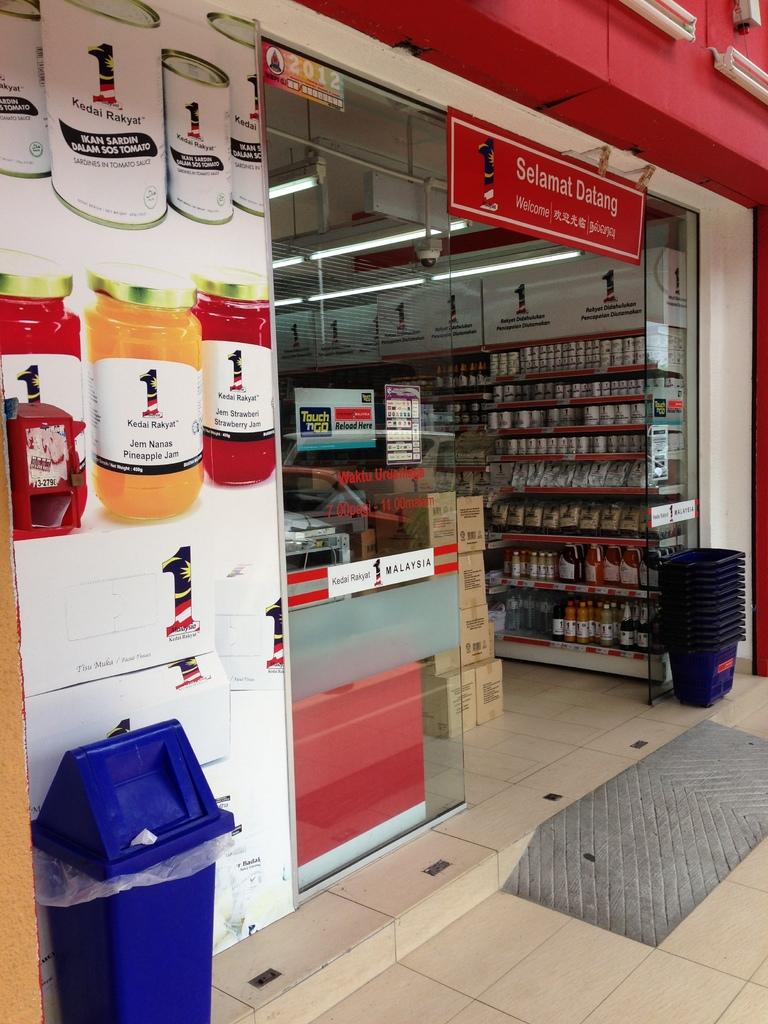What does the header on the red banner hanging above the entrance say?
Offer a terse response. Selamat datang. What kind of jams are on the poster?
Offer a terse response. Kedai rakyat. 